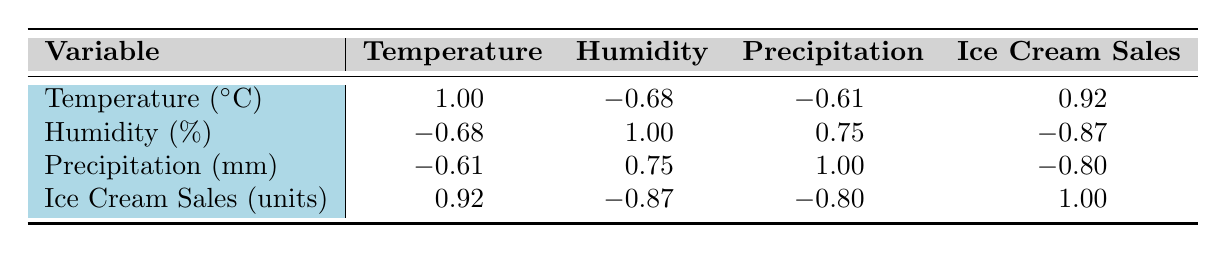What is the correlation between temperature and ice cream sales? The correlation value between temperature and ice cream sales is 0.92 as indicated in the table. This high positive correlation suggests that as the temperature increases, ice cream sales tend to increase as well.
Answer: 0.92 Is there a relationship between humidity and ice cream sales? The correlation between humidity and ice cream sales is -0.87, indicating a strong negative relationship. This means that as humidity increases, ice cream sales tend to decrease.
Answer: Yes What is the correlation between precipitation and ice cream sales? The table shows a correlation of -0.80 between precipitation and ice cream sales. This indicates a strong negative correlation, suggesting that increased precipitation is associated with lower ice cream sales.
Answer: -0.80 Which weather condition has the highest negative correlation with ice cream sales? The correlations with ice cream sales are -0.87 for humidity and -0.80 for precipitation. The highest negative correlation is thus with humidity, at -0.87.
Answer: Humidity What would be the average correlation value between temperature and precipitation based on the table? The correlation values are 1.00 for temperature with itself and -0.61 for precipitation with temperature. The average correlation value would be (1.00 - 0.61)/2 = 0.195.
Answer: 0.195 Is the correlation between precipitation and humidity positive or negative? The table shows a correlation of 0.75 between precipitation and humidity, which is a positive correlation. This means that higher humidity is associated with higher precipitation.
Answer: Positive How does the correlation of temperature compare with the correlation of humidity to ice cream sales? The correlation of temperature to ice cream sales is 0.92 and for humidity, it is -0.87. The former is a positive correlation indicating increased sales with higher temperatures, while the latter is negative, indicating decreased sales with increased humidity.
Answer: Temperature is positively correlated, while humidity is negatively correlated What is the combined effect of temperature and humidity on ice cream sales? Temperature has a strong positive effect with a correlation of 0.92, while humidity has a strong negative effect of -0.87. The combined effect suggests that high temperature increases ice cream sales, but high humidity decreases them. Overall, the positive effect of temperature may dominate.
Answer: Temperature increases, humidity decreases sales If the temperature increases by 2 degrees, what can be inferred about ice cream sales based on correlation? Given the strong positive correlation of 0.92 between temperature and ice cream sales, an increase of 2 degrees may lead to a significant increase in sales, though the exact change can't be determined without more data.
Answer: Significant increase expected 